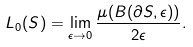Convert formula to latex. <formula><loc_0><loc_0><loc_500><loc_500>L _ { 0 } ( S ) = \lim _ { \epsilon \to 0 } \frac { \mu ( B ( \partial S , \epsilon ) ) } { 2 \epsilon } .</formula> 